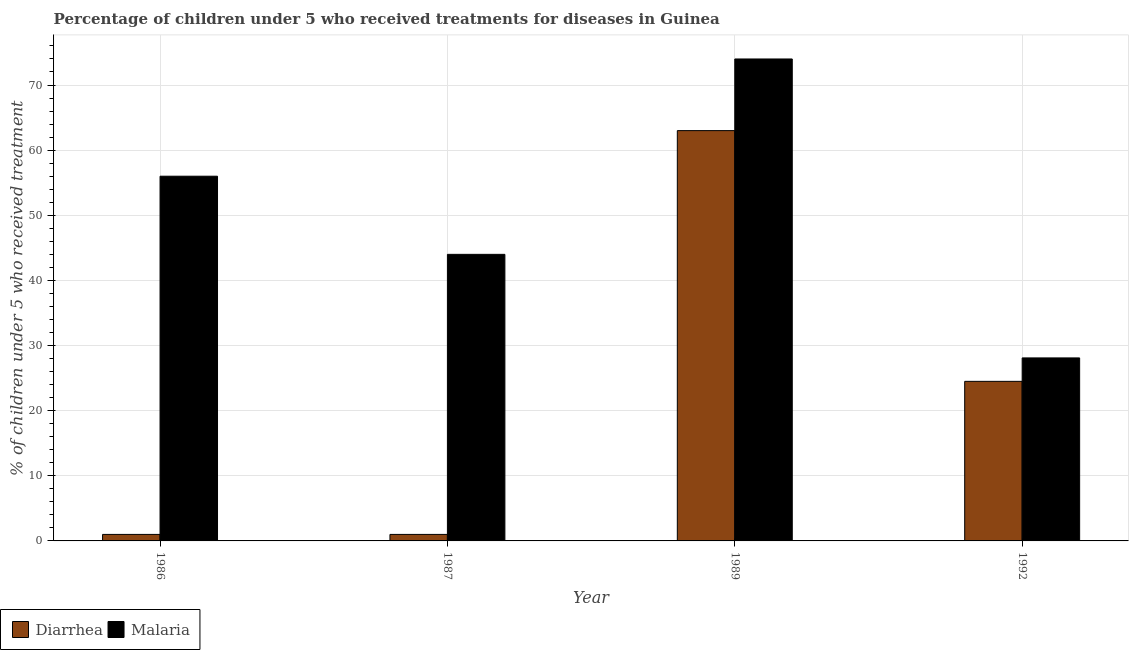How many groups of bars are there?
Keep it short and to the point. 4. Are the number of bars per tick equal to the number of legend labels?
Your answer should be compact. Yes. Are the number of bars on each tick of the X-axis equal?
Your answer should be very brief. Yes. How many bars are there on the 1st tick from the left?
Your answer should be compact. 2. What is the percentage of children who received treatment for malaria in 1992?
Make the answer very short. 28.1. Across all years, what is the minimum percentage of children who received treatment for diarrhoea?
Offer a very short reply. 1. What is the total percentage of children who received treatment for diarrhoea in the graph?
Provide a short and direct response. 89.5. What is the difference between the percentage of children who received treatment for diarrhoea in 1986 and that in 1987?
Your answer should be compact. 0. What is the difference between the percentage of children who received treatment for malaria in 1992 and the percentage of children who received treatment for diarrhoea in 1989?
Provide a succinct answer. -45.9. What is the average percentage of children who received treatment for malaria per year?
Your answer should be compact. 50.52. What is the ratio of the percentage of children who received treatment for diarrhoea in 1986 to that in 1989?
Provide a short and direct response. 0.02. Is the percentage of children who received treatment for malaria in 1986 less than that in 1987?
Your answer should be very brief. No. What is the difference between the highest and the second highest percentage of children who received treatment for diarrhoea?
Make the answer very short. 38.5. What is the difference between the highest and the lowest percentage of children who received treatment for malaria?
Make the answer very short. 45.9. Is the sum of the percentage of children who received treatment for malaria in 1989 and 1992 greater than the maximum percentage of children who received treatment for diarrhoea across all years?
Offer a terse response. Yes. What does the 1st bar from the left in 1992 represents?
Provide a succinct answer. Diarrhea. What does the 2nd bar from the right in 1986 represents?
Keep it short and to the point. Diarrhea. How many years are there in the graph?
Your answer should be compact. 4. What is the difference between two consecutive major ticks on the Y-axis?
Ensure brevity in your answer.  10. How are the legend labels stacked?
Offer a terse response. Horizontal. What is the title of the graph?
Ensure brevity in your answer.  Percentage of children under 5 who received treatments for diseases in Guinea. Does "Male labourers" appear as one of the legend labels in the graph?
Ensure brevity in your answer.  No. What is the label or title of the Y-axis?
Give a very brief answer. % of children under 5 who received treatment. What is the % of children under 5 who received treatment of Malaria in 1986?
Your response must be concise. 56. What is the % of children under 5 who received treatment in Diarrhea in 1987?
Make the answer very short. 1. What is the % of children under 5 who received treatment of Diarrhea in 1989?
Make the answer very short. 63. What is the % of children under 5 who received treatment of Malaria in 1992?
Ensure brevity in your answer.  28.1. Across all years, what is the maximum % of children under 5 who received treatment of Malaria?
Provide a succinct answer. 74. Across all years, what is the minimum % of children under 5 who received treatment of Malaria?
Make the answer very short. 28.1. What is the total % of children under 5 who received treatment of Diarrhea in the graph?
Ensure brevity in your answer.  89.5. What is the total % of children under 5 who received treatment in Malaria in the graph?
Your answer should be compact. 202.1. What is the difference between the % of children under 5 who received treatment of Diarrhea in 1986 and that in 1989?
Offer a very short reply. -62. What is the difference between the % of children under 5 who received treatment of Diarrhea in 1986 and that in 1992?
Make the answer very short. -23.5. What is the difference between the % of children under 5 who received treatment of Malaria in 1986 and that in 1992?
Ensure brevity in your answer.  27.9. What is the difference between the % of children under 5 who received treatment of Diarrhea in 1987 and that in 1989?
Ensure brevity in your answer.  -62. What is the difference between the % of children under 5 who received treatment in Diarrhea in 1987 and that in 1992?
Offer a very short reply. -23.5. What is the difference between the % of children under 5 who received treatment in Diarrhea in 1989 and that in 1992?
Offer a very short reply. 38.5. What is the difference between the % of children under 5 who received treatment of Malaria in 1989 and that in 1992?
Give a very brief answer. 45.9. What is the difference between the % of children under 5 who received treatment of Diarrhea in 1986 and the % of children under 5 who received treatment of Malaria in 1987?
Offer a very short reply. -43. What is the difference between the % of children under 5 who received treatment of Diarrhea in 1986 and the % of children under 5 who received treatment of Malaria in 1989?
Keep it short and to the point. -73. What is the difference between the % of children under 5 who received treatment in Diarrhea in 1986 and the % of children under 5 who received treatment in Malaria in 1992?
Your answer should be compact. -27.1. What is the difference between the % of children under 5 who received treatment of Diarrhea in 1987 and the % of children under 5 who received treatment of Malaria in 1989?
Make the answer very short. -73. What is the difference between the % of children under 5 who received treatment of Diarrhea in 1987 and the % of children under 5 who received treatment of Malaria in 1992?
Provide a short and direct response. -27.1. What is the difference between the % of children under 5 who received treatment in Diarrhea in 1989 and the % of children under 5 who received treatment in Malaria in 1992?
Make the answer very short. 34.9. What is the average % of children under 5 who received treatment of Diarrhea per year?
Offer a very short reply. 22.38. What is the average % of children under 5 who received treatment of Malaria per year?
Provide a short and direct response. 50.52. In the year 1986, what is the difference between the % of children under 5 who received treatment in Diarrhea and % of children under 5 who received treatment in Malaria?
Offer a very short reply. -55. In the year 1987, what is the difference between the % of children under 5 who received treatment of Diarrhea and % of children under 5 who received treatment of Malaria?
Ensure brevity in your answer.  -43. In the year 1989, what is the difference between the % of children under 5 who received treatment in Diarrhea and % of children under 5 who received treatment in Malaria?
Make the answer very short. -11. What is the ratio of the % of children under 5 who received treatment in Malaria in 1986 to that in 1987?
Your answer should be compact. 1.27. What is the ratio of the % of children under 5 who received treatment of Diarrhea in 1986 to that in 1989?
Keep it short and to the point. 0.02. What is the ratio of the % of children under 5 who received treatment of Malaria in 1986 to that in 1989?
Give a very brief answer. 0.76. What is the ratio of the % of children under 5 who received treatment of Diarrhea in 1986 to that in 1992?
Offer a terse response. 0.04. What is the ratio of the % of children under 5 who received treatment of Malaria in 1986 to that in 1992?
Give a very brief answer. 1.99. What is the ratio of the % of children under 5 who received treatment of Diarrhea in 1987 to that in 1989?
Provide a short and direct response. 0.02. What is the ratio of the % of children under 5 who received treatment of Malaria in 1987 to that in 1989?
Your answer should be compact. 0.59. What is the ratio of the % of children under 5 who received treatment of Diarrhea in 1987 to that in 1992?
Your answer should be very brief. 0.04. What is the ratio of the % of children under 5 who received treatment of Malaria in 1987 to that in 1992?
Keep it short and to the point. 1.57. What is the ratio of the % of children under 5 who received treatment of Diarrhea in 1989 to that in 1992?
Offer a terse response. 2.57. What is the ratio of the % of children under 5 who received treatment in Malaria in 1989 to that in 1992?
Your response must be concise. 2.63. What is the difference between the highest and the second highest % of children under 5 who received treatment of Diarrhea?
Keep it short and to the point. 38.5. What is the difference between the highest and the second highest % of children under 5 who received treatment of Malaria?
Make the answer very short. 18. What is the difference between the highest and the lowest % of children under 5 who received treatment of Diarrhea?
Provide a succinct answer. 62. What is the difference between the highest and the lowest % of children under 5 who received treatment in Malaria?
Offer a very short reply. 45.9. 